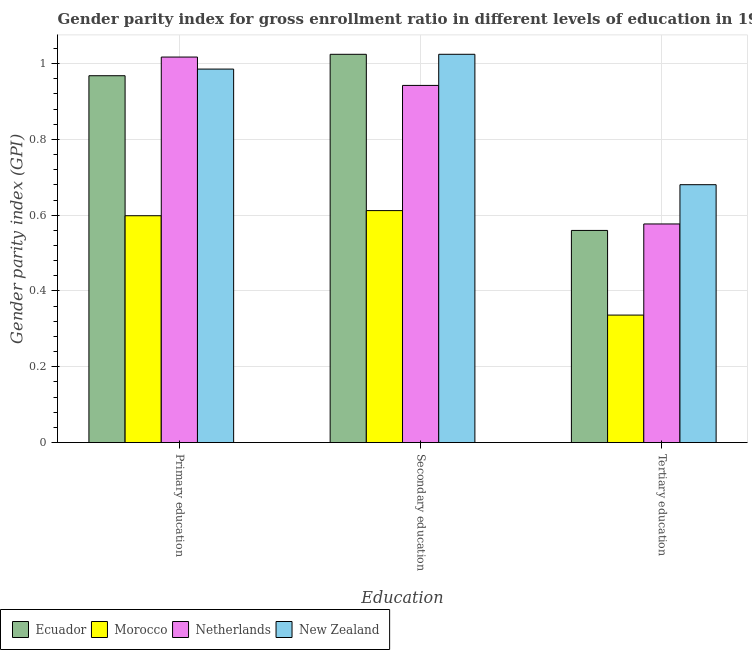How many bars are there on the 3rd tick from the right?
Ensure brevity in your answer.  4. What is the label of the 2nd group of bars from the left?
Offer a very short reply. Secondary education. What is the gender parity index in tertiary education in Netherlands?
Your response must be concise. 0.58. Across all countries, what is the maximum gender parity index in primary education?
Your response must be concise. 1.02. Across all countries, what is the minimum gender parity index in tertiary education?
Your answer should be very brief. 0.34. In which country was the gender parity index in primary education maximum?
Your answer should be compact. Netherlands. In which country was the gender parity index in tertiary education minimum?
Ensure brevity in your answer.  Morocco. What is the total gender parity index in tertiary education in the graph?
Provide a short and direct response. 2.15. What is the difference between the gender parity index in tertiary education in New Zealand and that in Netherlands?
Ensure brevity in your answer.  0.1. What is the difference between the gender parity index in tertiary education in Morocco and the gender parity index in secondary education in New Zealand?
Your answer should be very brief. -0.69. What is the average gender parity index in secondary education per country?
Offer a very short reply. 0.9. What is the difference between the gender parity index in primary education and gender parity index in tertiary education in New Zealand?
Offer a terse response. 0.3. In how many countries, is the gender parity index in tertiary education greater than 0.8400000000000001 ?
Provide a succinct answer. 0. What is the ratio of the gender parity index in primary education in New Zealand to that in Netherlands?
Offer a terse response. 0.97. Is the difference between the gender parity index in secondary education in Ecuador and New Zealand greater than the difference between the gender parity index in tertiary education in Ecuador and New Zealand?
Offer a terse response. Yes. What is the difference between the highest and the second highest gender parity index in secondary education?
Make the answer very short. 4.0000000000040004e-5. What is the difference between the highest and the lowest gender parity index in tertiary education?
Offer a terse response. 0.34. In how many countries, is the gender parity index in secondary education greater than the average gender parity index in secondary education taken over all countries?
Give a very brief answer. 3. Is the sum of the gender parity index in tertiary education in Ecuador and Netherlands greater than the maximum gender parity index in primary education across all countries?
Provide a succinct answer. Yes. What does the 2nd bar from the left in Primary education represents?
Provide a short and direct response. Morocco. What does the 4th bar from the right in Primary education represents?
Provide a short and direct response. Ecuador. Is it the case that in every country, the sum of the gender parity index in primary education and gender parity index in secondary education is greater than the gender parity index in tertiary education?
Keep it short and to the point. Yes. Are all the bars in the graph horizontal?
Ensure brevity in your answer.  No. How many countries are there in the graph?
Offer a very short reply. 4. Does the graph contain grids?
Offer a very short reply. Yes. Where does the legend appear in the graph?
Offer a very short reply. Bottom left. How many legend labels are there?
Keep it short and to the point. 4. What is the title of the graph?
Your response must be concise. Gender parity index for gross enrollment ratio in different levels of education in 1979. What is the label or title of the X-axis?
Keep it short and to the point. Education. What is the label or title of the Y-axis?
Keep it short and to the point. Gender parity index (GPI). What is the Gender parity index (GPI) in Ecuador in Primary education?
Offer a very short reply. 0.97. What is the Gender parity index (GPI) of Morocco in Primary education?
Give a very brief answer. 0.6. What is the Gender parity index (GPI) in Netherlands in Primary education?
Provide a succinct answer. 1.02. What is the Gender parity index (GPI) of New Zealand in Primary education?
Your answer should be very brief. 0.99. What is the Gender parity index (GPI) of Ecuador in Secondary education?
Offer a very short reply. 1.02. What is the Gender parity index (GPI) in Morocco in Secondary education?
Provide a short and direct response. 0.61. What is the Gender parity index (GPI) of Netherlands in Secondary education?
Keep it short and to the point. 0.94. What is the Gender parity index (GPI) of New Zealand in Secondary education?
Your response must be concise. 1.02. What is the Gender parity index (GPI) of Ecuador in Tertiary education?
Your answer should be very brief. 0.56. What is the Gender parity index (GPI) in Morocco in Tertiary education?
Your response must be concise. 0.34. What is the Gender parity index (GPI) of Netherlands in Tertiary education?
Provide a succinct answer. 0.58. What is the Gender parity index (GPI) in New Zealand in Tertiary education?
Give a very brief answer. 0.68. Across all Education, what is the maximum Gender parity index (GPI) in Ecuador?
Make the answer very short. 1.02. Across all Education, what is the maximum Gender parity index (GPI) of Morocco?
Your response must be concise. 0.61. Across all Education, what is the maximum Gender parity index (GPI) in Netherlands?
Provide a succinct answer. 1.02. Across all Education, what is the maximum Gender parity index (GPI) in New Zealand?
Provide a succinct answer. 1.02. Across all Education, what is the minimum Gender parity index (GPI) in Ecuador?
Make the answer very short. 0.56. Across all Education, what is the minimum Gender parity index (GPI) of Morocco?
Make the answer very short. 0.34. Across all Education, what is the minimum Gender parity index (GPI) of Netherlands?
Make the answer very short. 0.58. Across all Education, what is the minimum Gender parity index (GPI) in New Zealand?
Offer a terse response. 0.68. What is the total Gender parity index (GPI) in Ecuador in the graph?
Make the answer very short. 2.55. What is the total Gender parity index (GPI) in Morocco in the graph?
Offer a terse response. 1.55. What is the total Gender parity index (GPI) in Netherlands in the graph?
Your answer should be compact. 2.54. What is the total Gender parity index (GPI) in New Zealand in the graph?
Keep it short and to the point. 2.69. What is the difference between the Gender parity index (GPI) of Ecuador in Primary education and that in Secondary education?
Ensure brevity in your answer.  -0.06. What is the difference between the Gender parity index (GPI) in Morocco in Primary education and that in Secondary education?
Keep it short and to the point. -0.01. What is the difference between the Gender parity index (GPI) of Netherlands in Primary education and that in Secondary education?
Offer a very short reply. 0.07. What is the difference between the Gender parity index (GPI) of New Zealand in Primary education and that in Secondary education?
Offer a terse response. -0.04. What is the difference between the Gender parity index (GPI) of Ecuador in Primary education and that in Tertiary education?
Keep it short and to the point. 0.41. What is the difference between the Gender parity index (GPI) of Morocco in Primary education and that in Tertiary education?
Provide a succinct answer. 0.26. What is the difference between the Gender parity index (GPI) of Netherlands in Primary education and that in Tertiary education?
Offer a terse response. 0.44. What is the difference between the Gender parity index (GPI) in New Zealand in Primary education and that in Tertiary education?
Give a very brief answer. 0.3. What is the difference between the Gender parity index (GPI) in Ecuador in Secondary education and that in Tertiary education?
Your answer should be compact. 0.46. What is the difference between the Gender parity index (GPI) in Morocco in Secondary education and that in Tertiary education?
Offer a terse response. 0.28. What is the difference between the Gender parity index (GPI) in Netherlands in Secondary education and that in Tertiary education?
Provide a short and direct response. 0.37. What is the difference between the Gender parity index (GPI) of New Zealand in Secondary education and that in Tertiary education?
Offer a very short reply. 0.34. What is the difference between the Gender parity index (GPI) of Ecuador in Primary education and the Gender parity index (GPI) of Morocco in Secondary education?
Make the answer very short. 0.36. What is the difference between the Gender parity index (GPI) of Ecuador in Primary education and the Gender parity index (GPI) of Netherlands in Secondary education?
Make the answer very short. 0.03. What is the difference between the Gender parity index (GPI) of Ecuador in Primary education and the Gender parity index (GPI) of New Zealand in Secondary education?
Offer a very short reply. -0.06. What is the difference between the Gender parity index (GPI) in Morocco in Primary education and the Gender parity index (GPI) in Netherlands in Secondary education?
Your answer should be compact. -0.34. What is the difference between the Gender parity index (GPI) of Morocco in Primary education and the Gender parity index (GPI) of New Zealand in Secondary education?
Your response must be concise. -0.43. What is the difference between the Gender parity index (GPI) in Netherlands in Primary education and the Gender parity index (GPI) in New Zealand in Secondary education?
Your response must be concise. -0.01. What is the difference between the Gender parity index (GPI) of Ecuador in Primary education and the Gender parity index (GPI) of Morocco in Tertiary education?
Offer a terse response. 0.63. What is the difference between the Gender parity index (GPI) of Ecuador in Primary education and the Gender parity index (GPI) of Netherlands in Tertiary education?
Offer a terse response. 0.39. What is the difference between the Gender parity index (GPI) in Ecuador in Primary education and the Gender parity index (GPI) in New Zealand in Tertiary education?
Ensure brevity in your answer.  0.29. What is the difference between the Gender parity index (GPI) in Morocco in Primary education and the Gender parity index (GPI) in Netherlands in Tertiary education?
Offer a very short reply. 0.02. What is the difference between the Gender parity index (GPI) of Morocco in Primary education and the Gender parity index (GPI) of New Zealand in Tertiary education?
Keep it short and to the point. -0.08. What is the difference between the Gender parity index (GPI) in Netherlands in Primary education and the Gender parity index (GPI) in New Zealand in Tertiary education?
Offer a terse response. 0.34. What is the difference between the Gender parity index (GPI) of Ecuador in Secondary education and the Gender parity index (GPI) of Morocco in Tertiary education?
Provide a short and direct response. 0.69. What is the difference between the Gender parity index (GPI) of Ecuador in Secondary education and the Gender parity index (GPI) of Netherlands in Tertiary education?
Ensure brevity in your answer.  0.45. What is the difference between the Gender parity index (GPI) of Ecuador in Secondary education and the Gender parity index (GPI) of New Zealand in Tertiary education?
Your answer should be compact. 0.34. What is the difference between the Gender parity index (GPI) in Morocco in Secondary education and the Gender parity index (GPI) in Netherlands in Tertiary education?
Give a very brief answer. 0.04. What is the difference between the Gender parity index (GPI) in Morocco in Secondary education and the Gender parity index (GPI) in New Zealand in Tertiary education?
Offer a very short reply. -0.07. What is the difference between the Gender parity index (GPI) of Netherlands in Secondary education and the Gender parity index (GPI) of New Zealand in Tertiary education?
Your answer should be very brief. 0.26. What is the average Gender parity index (GPI) of Ecuador per Education?
Keep it short and to the point. 0.85. What is the average Gender parity index (GPI) of Morocco per Education?
Make the answer very short. 0.52. What is the average Gender parity index (GPI) of Netherlands per Education?
Give a very brief answer. 0.85. What is the average Gender parity index (GPI) of New Zealand per Education?
Offer a terse response. 0.9. What is the difference between the Gender parity index (GPI) of Ecuador and Gender parity index (GPI) of Morocco in Primary education?
Ensure brevity in your answer.  0.37. What is the difference between the Gender parity index (GPI) of Ecuador and Gender parity index (GPI) of Netherlands in Primary education?
Your response must be concise. -0.05. What is the difference between the Gender parity index (GPI) of Ecuador and Gender parity index (GPI) of New Zealand in Primary education?
Provide a short and direct response. -0.02. What is the difference between the Gender parity index (GPI) in Morocco and Gender parity index (GPI) in Netherlands in Primary education?
Offer a very short reply. -0.42. What is the difference between the Gender parity index (GPI) of Morocco and Gender parity index (GPI) of New Zealand in Primary education?
Your response must be concise. -0.39. What is the difference between the Gender parity index (GPI) in Netherlands and Gender parity index (GPI) in New Zealand in Primary education?
Your answer should be very brief. 0.03. What is the difference between the Gender parity index (GPI) of Ecuador and Gender parity index (GPI) of Morocco in Secondary education?
Give a very brief answer. 0.41. What is the difference between the Gender parity index (GPI) in Ecuador and Gender parity index (GPI) in Netherlands in Secondary education?
Ensure brevity in your answer.  0.08. What is the difference between the Gender parity index (GPI) of Morocco and Gender parity index (GPI) of Netherlands in Secondary education?
Give a very brief answer. -0.33. What is the difference between the Gender parity index (GPI) of Morocco and Gender parity index (GPI) of New Zealand in Secondary education?
Give a very brief answer. -0.41. What is the difference between the Gender parity index (GPI) in Netherlands and Gender parity index (GPI) in New Zealand in Secondary education?
Keep it short and to the point. -0.08. What is the difference between the Gender parity index (GPI) of Ecuador and Gender parity index (GPI) of Morocco in Tertiary education?
Your answer should be very brief. 0.22. What is the difference between the Gender parity index (GPI) of Ecuador and Gender parity index (GPI) of Netherlands in Tertiary education?
Keep it short and to the point. -0.02. What is the difference between the Gender parity index (GPI) in Ecuador and Gender parity index (GPI) in New Zealand in Tertiary education?
Your answer should be compact. -0.12. What is the difference between the Gender parity index (GPI) of Morocco and Gender parity index (GPI) of Netherlands in Tertiary education?
Keep it short and to the point. -0.24. What is the difference between the Gender parity index (GPI) in Morocco and Gender parity index (GPI) in New Zealand in Tertiary education?
Keep it short and to the point. -0.34. What is the difference between the Gender parity index (GPI) in Netherlands and Gender parity index (GPI) in New Zealand in Tertiary education?
Offer a very short reply. -0.1. What is the ratio of the Gender parity index (GPI) of Ecuador in Primary education to that in Secondary education?
Provide a short and direct response. 0.94. What is the ratio of the Gender parity index (GPI) of Morocco in Primary education to that in Secondary education?
Your answer should be compact. 0.98. What is the ratio of the Gender parity index (GPI) in Netherlands in Primary education to that in Secondary education?
Ensure brevity in your answer.  1.08. What is the ratio of the Gender parity index (GPI) in New Zealand in Primary education to that in Secondary education?
Make the answer very short. 0.96. What is the ratio of the Gender parity index (GPI) of Ecuador in Primary education to that in Tertiary education?
Give a very brief answer. 1.73. What is the ratio of the Gender parity index (GPI) of Morocco in Primary education to that in Tertiary education?
Keep it short and to the point. 1.78. What is the ratio of the Gender parity index (GPI) of Netherlands in Primary education to that in Tertiary education?
Offer a terse response. 1.76. What is the ratio of the Gender parity index (GPI) in New Zealand in Primary education to that in Tertiary education?
Offer a very short reply. 1.45. What is the ratio of the Gender parity index (GPI) in Ecuador in Secondary education to that in Tertiary education?
Your answer should be compact. 1.83. What is the ratio of the Gender parity index (GPI) of Morocco in Secondary education to that in Tertiary education?
Ensure brevity in your answer.  1.82. What is the ratio of the Gender parity index (GPI) in Netherlands in Secondary education to that in Tertiary education?
Offer a terse response. 1.63. What is the ratio of the Gender parity index (GPI) of New Zealand in Secondary education to that in Tertiary education?
Your answer should be compact. 1.51. What is the difference between the highest and the second highest Gender parity index (GPI) of Ecuador?
Offer a very short reply. 0.06. What is the difference between the highest and the second highest Gender parity index (GPI) in Morocco?
Ensure brevity in your answer.  0.01. What is the difference between the highest and the second highest Gender parity index (GPI) in Netherlands?
Provide a succinct answer. 0.07. What is the difference between the highest and the second highest Gender parity index (GPI) in New Zealand?
Offer a terse response. 0.04. What is the difference between the highest and the lowest Gender parity index (GPI) in Ecuador?
Your answer should be very brief. 0.46. What is the difference between the highest and the lowest Gender parity index (GPI) of Morocco?
Your answer should be very brief. 0.28. What is the difference between the highest and the lowest Gender parity index (GPI) of Netherlands?
Make the answer very short. 0.44. What is the difference between the highest and the lowest Gender parity index (GPI) in New Zealand?
Offer a very short reply. 0.34. 